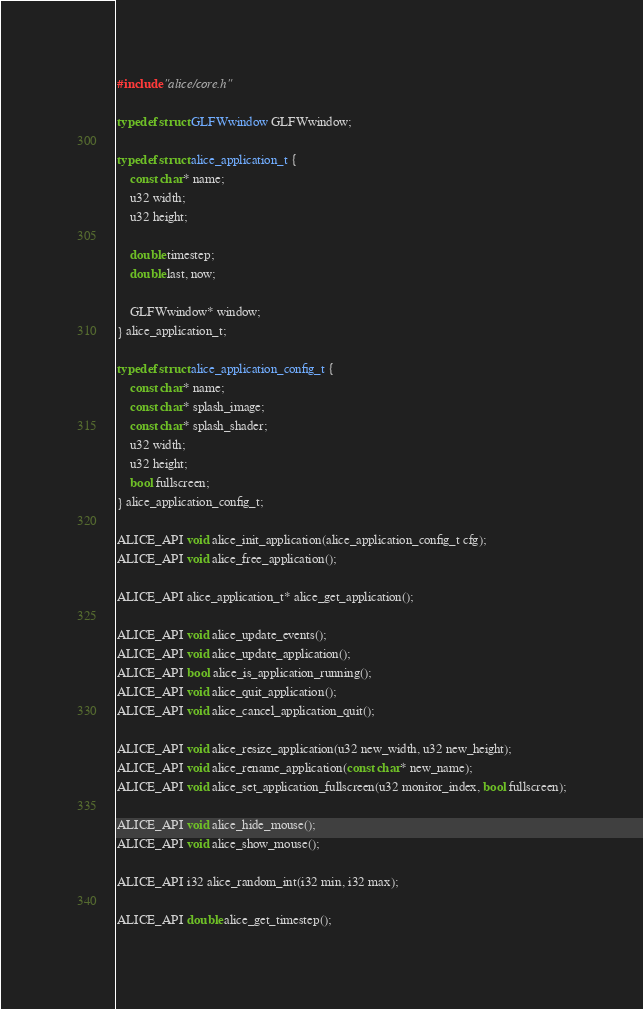<code> <loc_0><loc_0><loc_500><loc_500><_C_>
#include "alice/core.h"

typedef struct GLFWwindow GLFWwindow;

typedef struct alice_application_t {
	const char* name;
	u32 width;
	u32 height;

	double timestep;
	double last, now;

	GLFWwindow* window;
} alice_application_t;

typedef struct alice_application_config_t {
	const char* name;
	const char* splash_image;
	const char* splash_shader;
	u32 width;
	u32 height;
	bool fullscreen;
} alice_application_config_t;

ALICE_API void alice_init_application(alice_application_config_t cfg);
ALICE_API void alice_free_application();

ALICE_API alice_application_t* alice_get_application();

ALICE_API void alice_update_events();
ALICE_API void alice_update_application();
ALICE_API bool alice_is_application_running();
ALICE_API void alice_quit_application();
ALICE_API void alice_cancel_application_quit();

ALICE_API void alice_resize_application(u32 new_width, u32 new_height);
ALICE_API void alice_rename_application(const char* new_name);
ALICE_API void alice_set_application_fullscreen(u32 monitor_index, bool fullscreen);

ALICE_API void alice_hide_mouse();
ALICE_API void alice_show_mouse();

ALICE_API i32 alice_random_int(i32 min, i32 max);

ALICE_API double alice_get_timestep();
</code> 